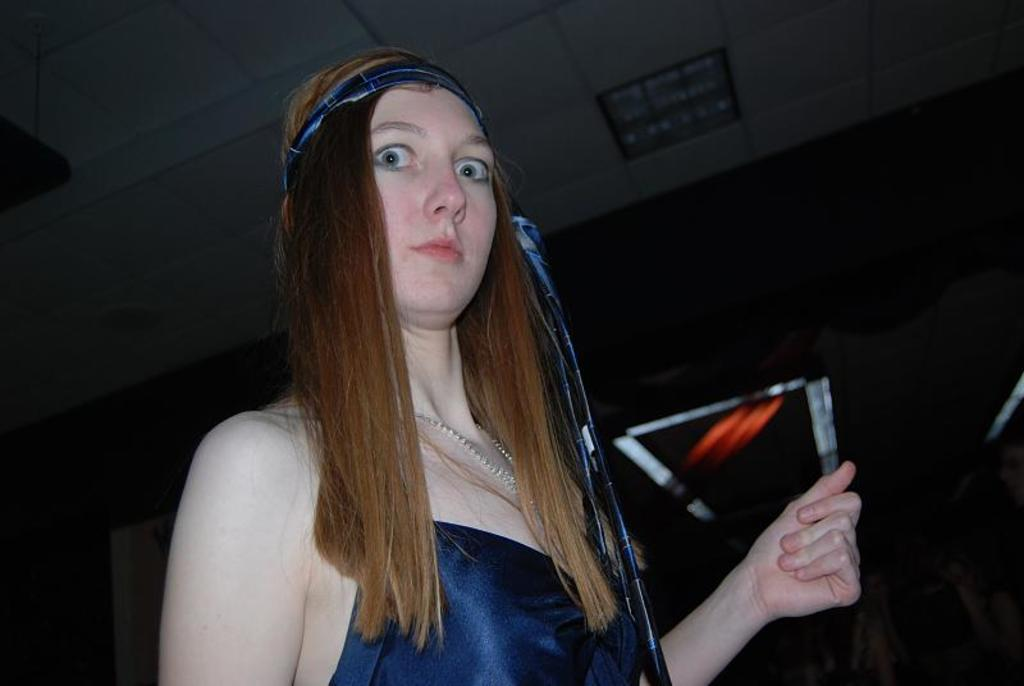Who is the main subject in the image? There is a woman in the image. What is the woman wearing? The woman is wearing a blue dress. Are there any accessories visible on the woman? Yes, the woman has a blue band on her head. What type of feather can be seen on the woman's dress in the image? There is no feather visible on the woman's dress in the image. Is the woman in the image a visitor? The image does not provide any information about the woman's status as a visitor or relation to others. 